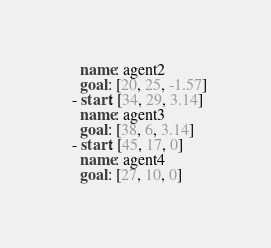Convert code to text. <code><loc_0><loc_0><loc_500><loc_500><_YAML_>    name: agent2
    goal: [20, 25, -1.57]
  - start: [34, 29, 3.14]
    name: agent3
    goal: [38, 6, 3.14]
  - start: [45, 17, 0]
    name: agent4
    goal: [27, 10, 0]</code> 